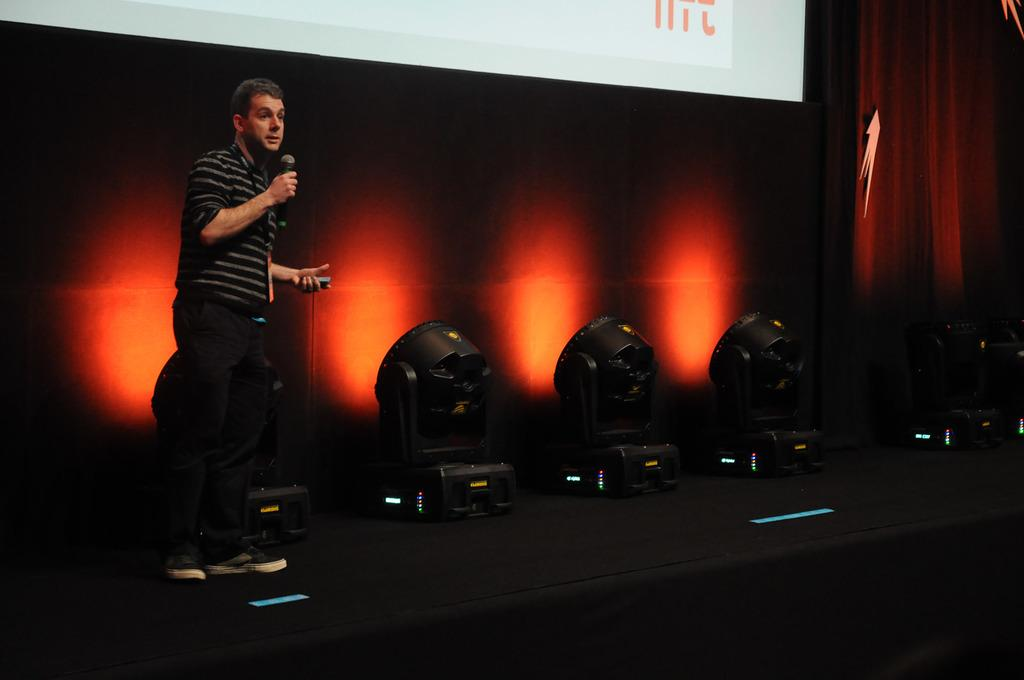What is the man in the image doing on the stage? The man is standing on the stage and speaking on a microphone. What is used to amplify the man's voice in the image? The man is speaking on a microphone, which is used to amplify his voice. What type of lighting is visible in the image? There are black spotlights visible in the image. What can be seen in the background of the image? There is a red banner in the background of the image. What type of insurance policy is being discussed on the stage in the image? There is no mention of insurance in the image; the man is speaking on a microphone while standing on the stage. Can you see any pipes in the image? There are no pipes visible in the image. 